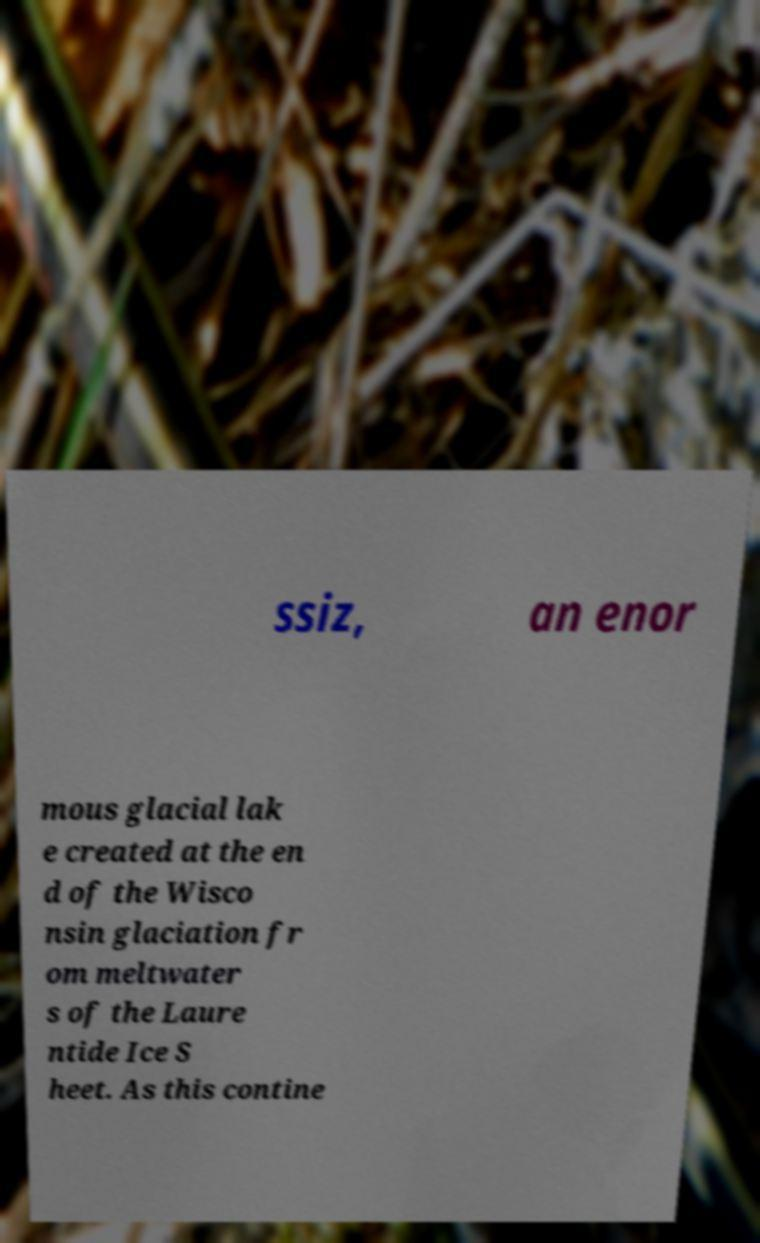Could you assist in decoding the text presented in this image and type it out clearly? ssiz, an enor mous glacial lak e created at the en d of the Wisco nsin glaciation fr om meltwater s of the Laure ntide Ice S heet. As this contine 